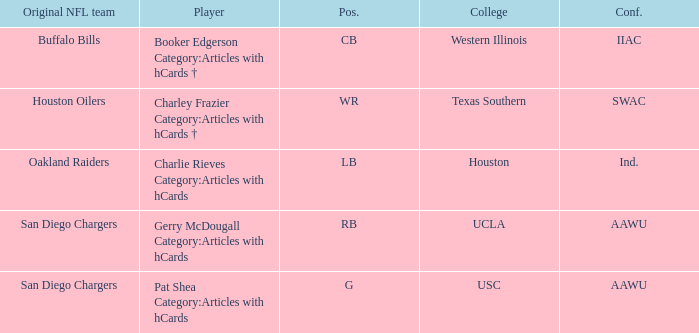Whose starting team are the oakland raiders? Charlie Rieves Category:Articles with hCards. 